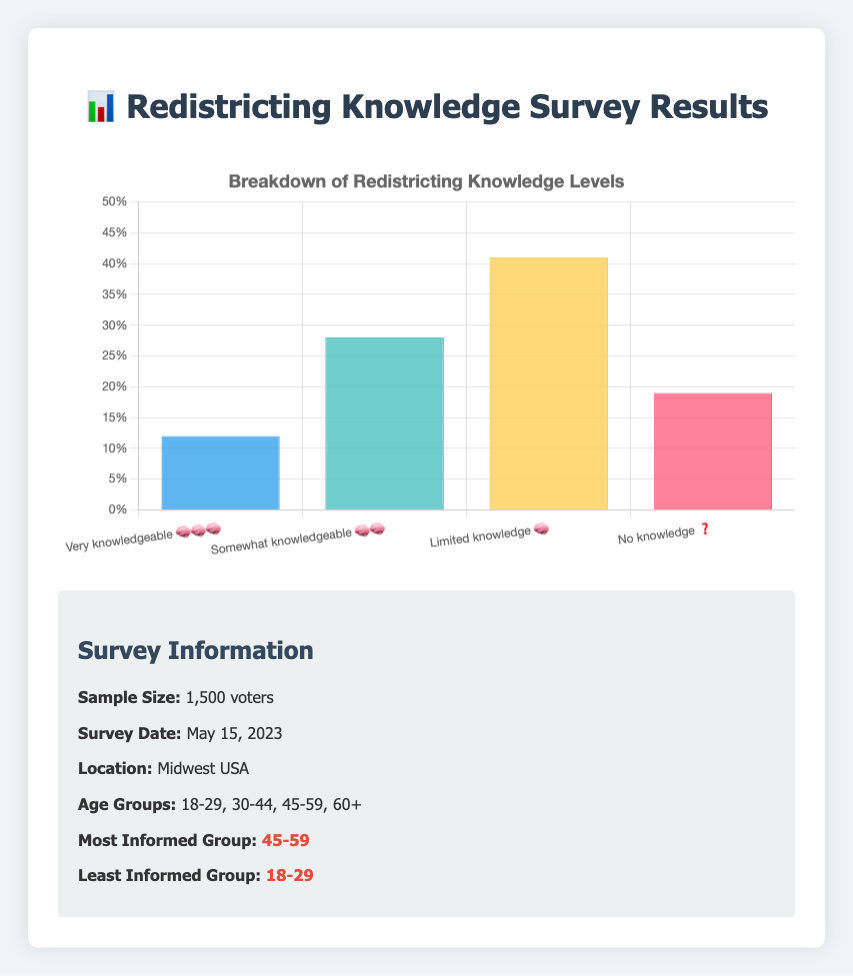What percentage of surveyed voters reported being "Very knowledgeable 🧠🧠🧠"? According to the chart, look for the bar labeled "Very knowledgeable 🧠🧠🧠" and read its height.
Answer: 12% Which knowledge level has the highest percentage of voters? Identify the tallest bar in the chart. The bar with the highest height indicates the greatest percentage.
Answer: Limited knowledge 🧠 How many percentage points more are there in the "Limited knowledge 🧠" category compared to the "Very knowledgeable 🧠🧠🧠" category? Subtract the percentage of "Very knowledgeable 🧠🧠🧠" from the percentage of "Limited knowledge 🧠" (i.e., 41% - 12%).
Answer: 29 What is the combined percentage of voters who have "Somewhat knowledgeable 🧠🧠" and "No knowledge ❓"? Add the percentages of "Somewhat knowledgeable 🧠🧠" and "No knowledge ❓", i.e., 28% + 19%.
Answer: 47% Which age group is the most informed according to the survey? Refer to the survey details section where the most informed age group is highlighted.
Answer: 45-59 Which knowledge level has fewer voters than the "No knowledge ❓" category? Compare the percentages of all categories to 19%, which is the percentage for "No knowledge ❓". The category with a lesser percentage is "Very knowledgeable 🧠🧠🧠".
Answer: Very knowledgeable 🧠🧠🧠 What percentage of the surveyed population falls in the category of "Somewhat knowledgeable 🧠🧠"? Look for the bar labeled "Somewhat knowledgeable 🧠🧠" and check its height.
Answer: 28% What is the difference in percentage between voters with "Somewhat knowledgeable 🧠🧠" and those with "No knowledge ❓"? Subtract the percentage of "No knowledge ❓" from "Somewhat knowledgeable 🧠🧠" (i.e., 28% - 19%).
Answer: 9 How many age groups are represented in the survey? Refer to the survey details where the age groups are listed. Count the number of age groups mentioned.
Answer: 4 What is the title of the chart depicting the redistricting knowledge levels? Look at the top of the chart where the title is usually provided.
Answer: Breakdown of Redistricting Knowledge Levels 